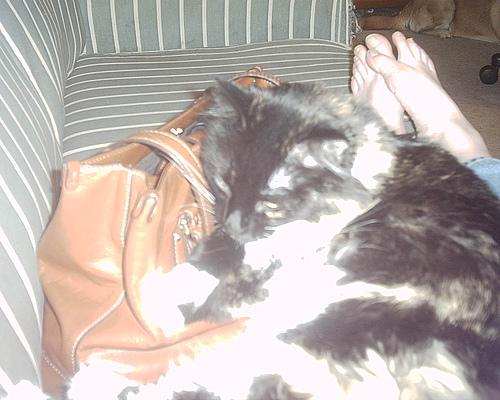Where does the cat rest? couch 